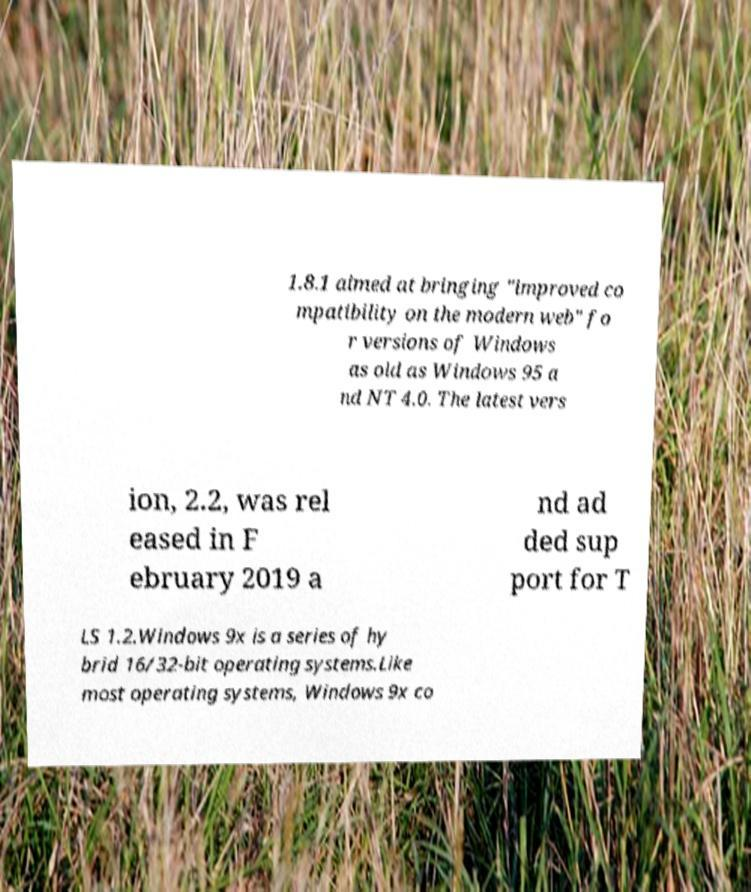Please identify and transcribe the text found in this image. 1.8.1 aimed at bringing "improved co mpatibility on the modern web" fo r versions of Windows as old as Windows 95 a nd NT 4.0. The latest vers ion, 2.2, was rel eased in F ebruary 2019 a nd ad ded sup port for T LS 1.2.Windows 9x is a series of hy brid 16/32-bit operating systems.Like most operating systems, Windows 9x co 